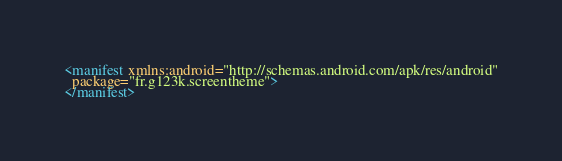Convert code to text. <code><loc_0><loc_0><loc_500><loc_500><_XML_><manifest xmlns:android="http://schemas.android.com/apk/res/android"
  package="fr.g123k.screentheme">
</manifest>
</code> 